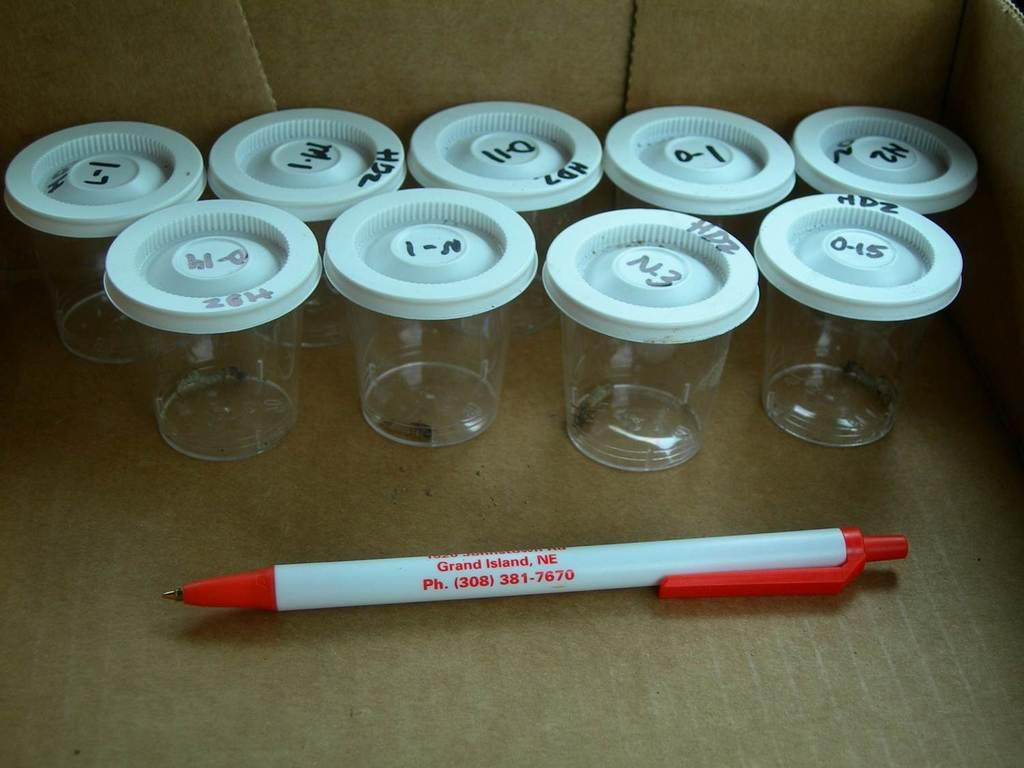Where was the image taken? The image is taken inside a box. What can be seen in the middle of the box? There is a pen in the middle of the box. What else is visible in the background of the box? There are glasses with caps in the background of the box. What type of neck accessory is visible in the image? There is no neck accessory present in the image. How are the glasses being transported in the image? The image does not show the glasses being transported; it only shows them with caps in the background. 